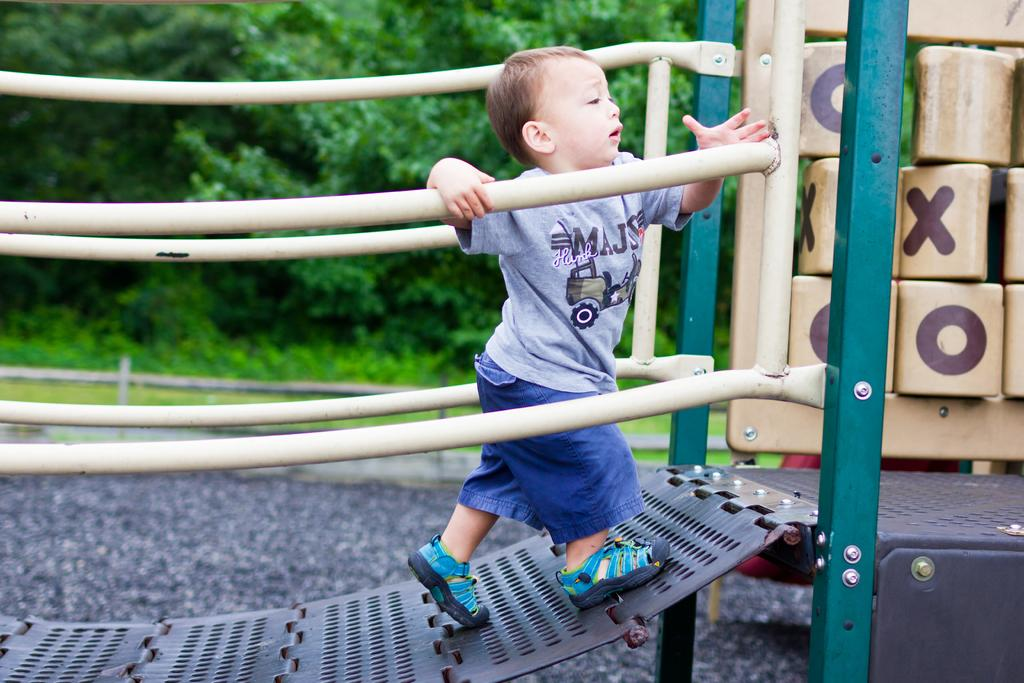What is the main subject of the image? There is a boy walking in the image. What objects can be seen in the image besides the boy? There are rods and poles in the image. What is the general setting of the image? The background of the image contains greenery. How many types of objects can be seen in the image? There are at least three types of objects: the boy, rods, and poles. What type of drug is the boy holding in the image? There is no drug present in the image; the boy is walking and there are rods and poles visible. 